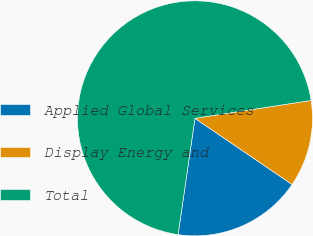Convert chart to OTSL. <chart><loc_0><loc_0><loc_500><loc_500><pie_chart><fcel>Applied Global Services<fcel>Display Energy and<fcel>Total<nl><fcel>17.78%<fcel>11.95%<fcel>70.27%<nl></chart> 